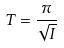<formula> <loc_0><loc_0><loc_500><loc_500>T = \frac { \pi } { \sqrt { I } }</formula> 